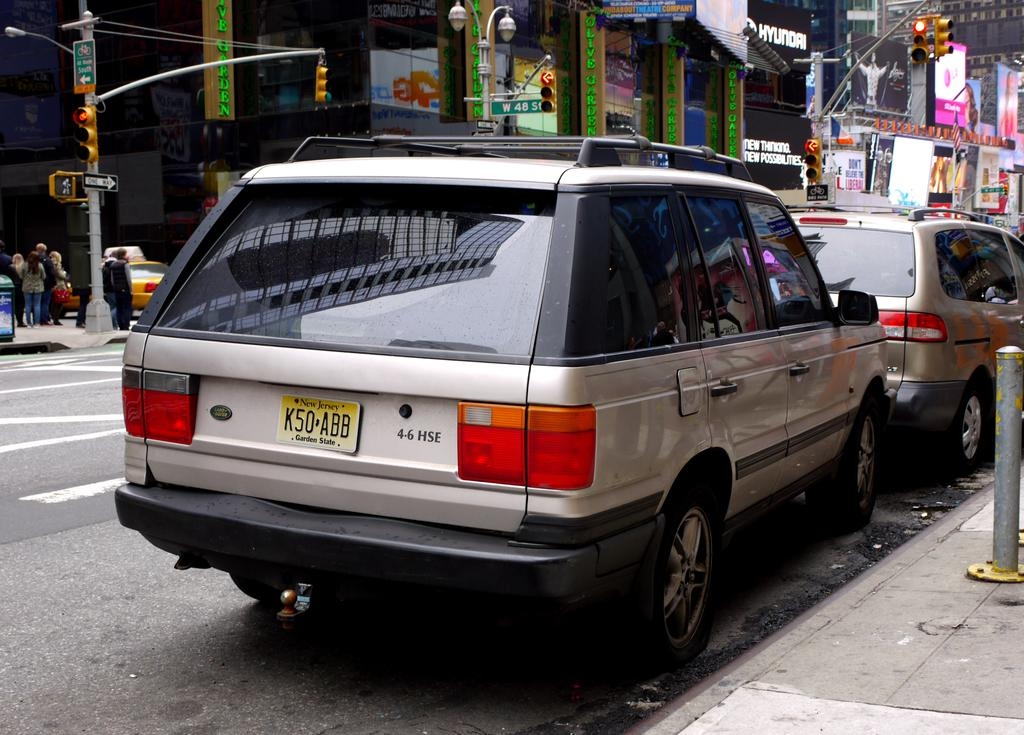What type of vehicles can be seen on the roads in the image? There are cars on the roads in the image. Where are the people located in the image? The people are present on the left side of the image. What helps regulate the flow of traffic in the image? There are traffic signals in the image. What type of structures can be seen in the image? There are buildings in the image. What color is the scarf worn by the person in the image? There is no scarf visible in the image; only people, cars, traffic signals, and buildings are present. What type of competition is taking place in the image? There is no competition present in the image; it features cars, people, traffic signals, and buildings. 